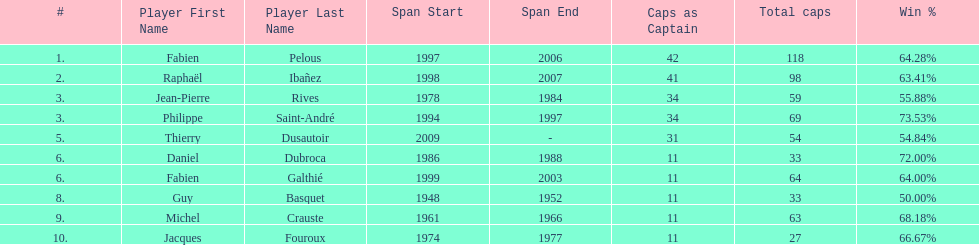How many caps did guy basquet accrue during his career? 33. 